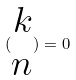Convert formula to latex. <formula><loc_0><loc_0><loc_500><loc_500>( \begin{matrix} k \\ n \end{matrix} ) = 0</formula> 